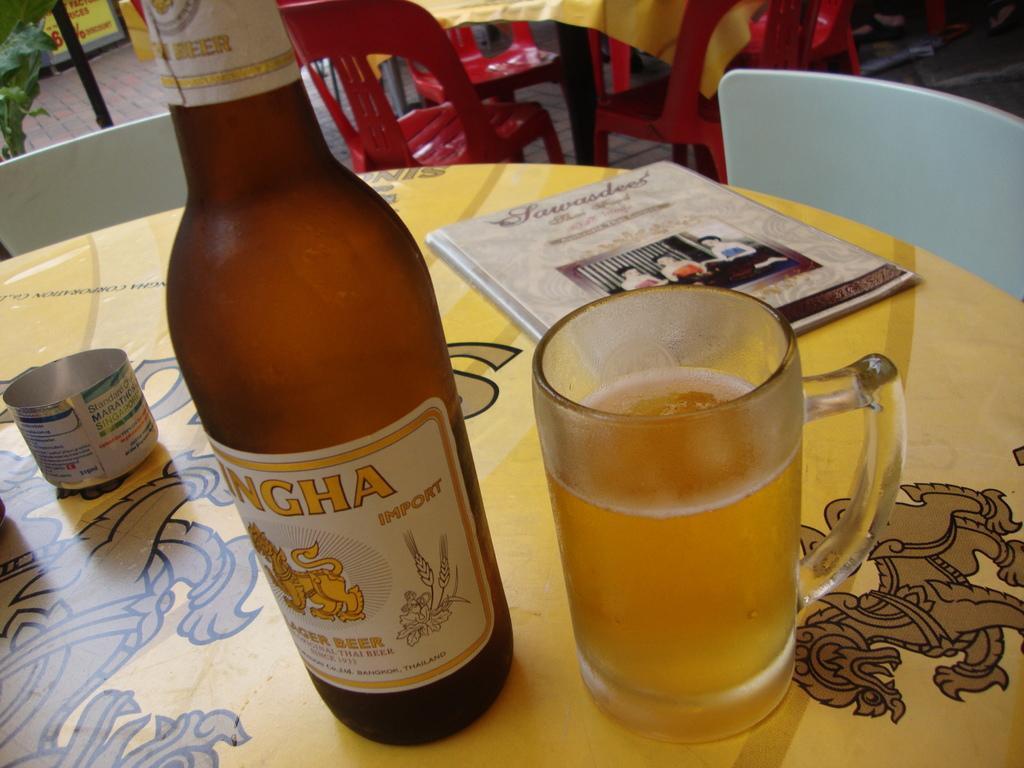Can you describe this image briefly? In this picture we can see a bottle, glass, and a book on the table. These are the chairs. And there is a plant. 